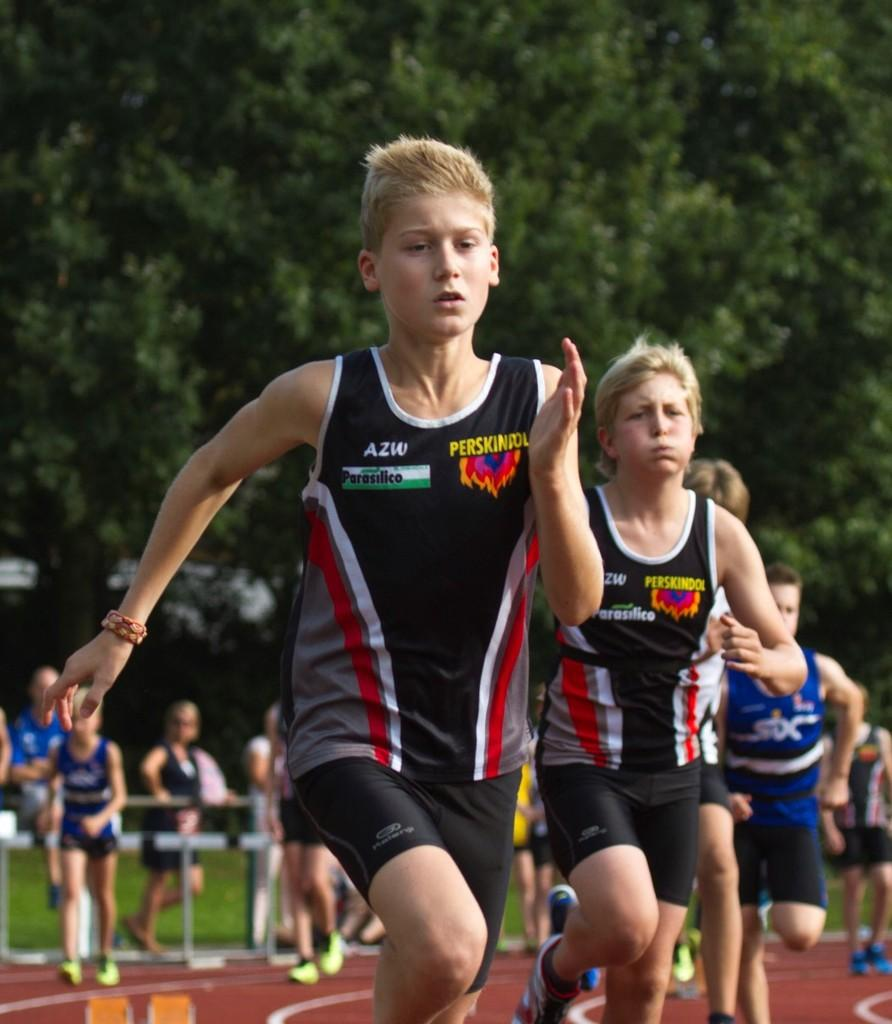<image>
Create a compact narrative representing the image presented. Several boys running on a track in jerseys that say Parasilico on them. 